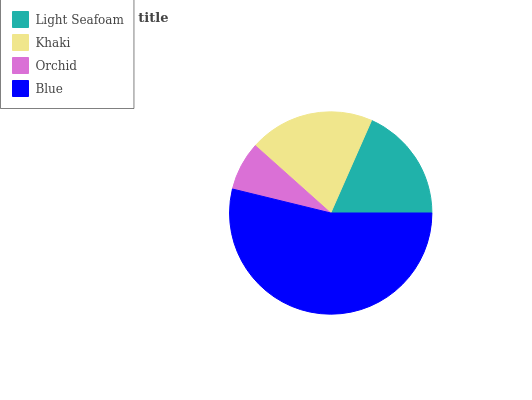Is Orchid the minimum?
Answer yes or no. Yes. Is Blue the maximum?
Answer yes or no. Yes. Is Khaki the minimum?
Answer yes or no. No. Is Khaki the maximum?
Answer yes or no. No. Is Khaki greater than Light Seafoam?
Answer yes or no. Yes. Is Light Seafoam less than Khaki?
Answer yes or no. Yes. Is Light Seafoam greater than Khaki?
Answer yes or no. No. Is Khaki less than Light Seafoam?
Answer yes or no. No. Is Khaki the high median?
Answer yes or no. Yes. Is Light Seafoam the low median?
Answer yes or no. Yes. Is Light Seafoam the high median?
Answer yes or no. No. Is Blue the low median?
Answer yes or no. No. 